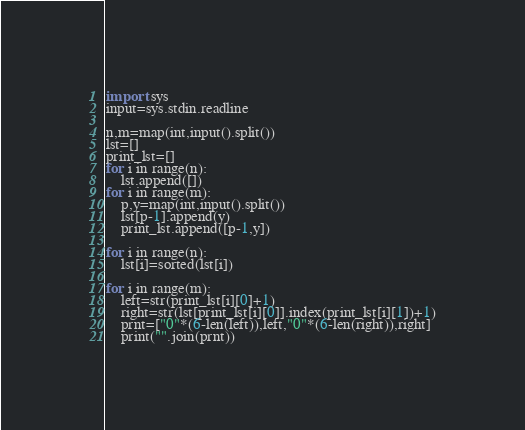<code> <loc_0><loc_0><loc_500><loc_500><_Python_>import sys
input=sys.stdin.readline

n,m=map(int,input().split())
lst=[]
print_lst=[]
for i in range(n):
    lst.append([])
for i in range(m):
    p,y=map(int,input().split())
    lst[p-1].append(y)
    print_lst.append([p-1,y])

for i in range(n):
    lst[i]=sorted(lst[i])

for i in range(m):
    left=str(print_lst[i][0]+1)
    right=str(lst[print_lst[i][0]].index(print_lst[i][1])+1)
    prnt=["0"*(6-len(left)),left,"0"*(6-len(right)),right]
    print("".join(prnt))</code> 